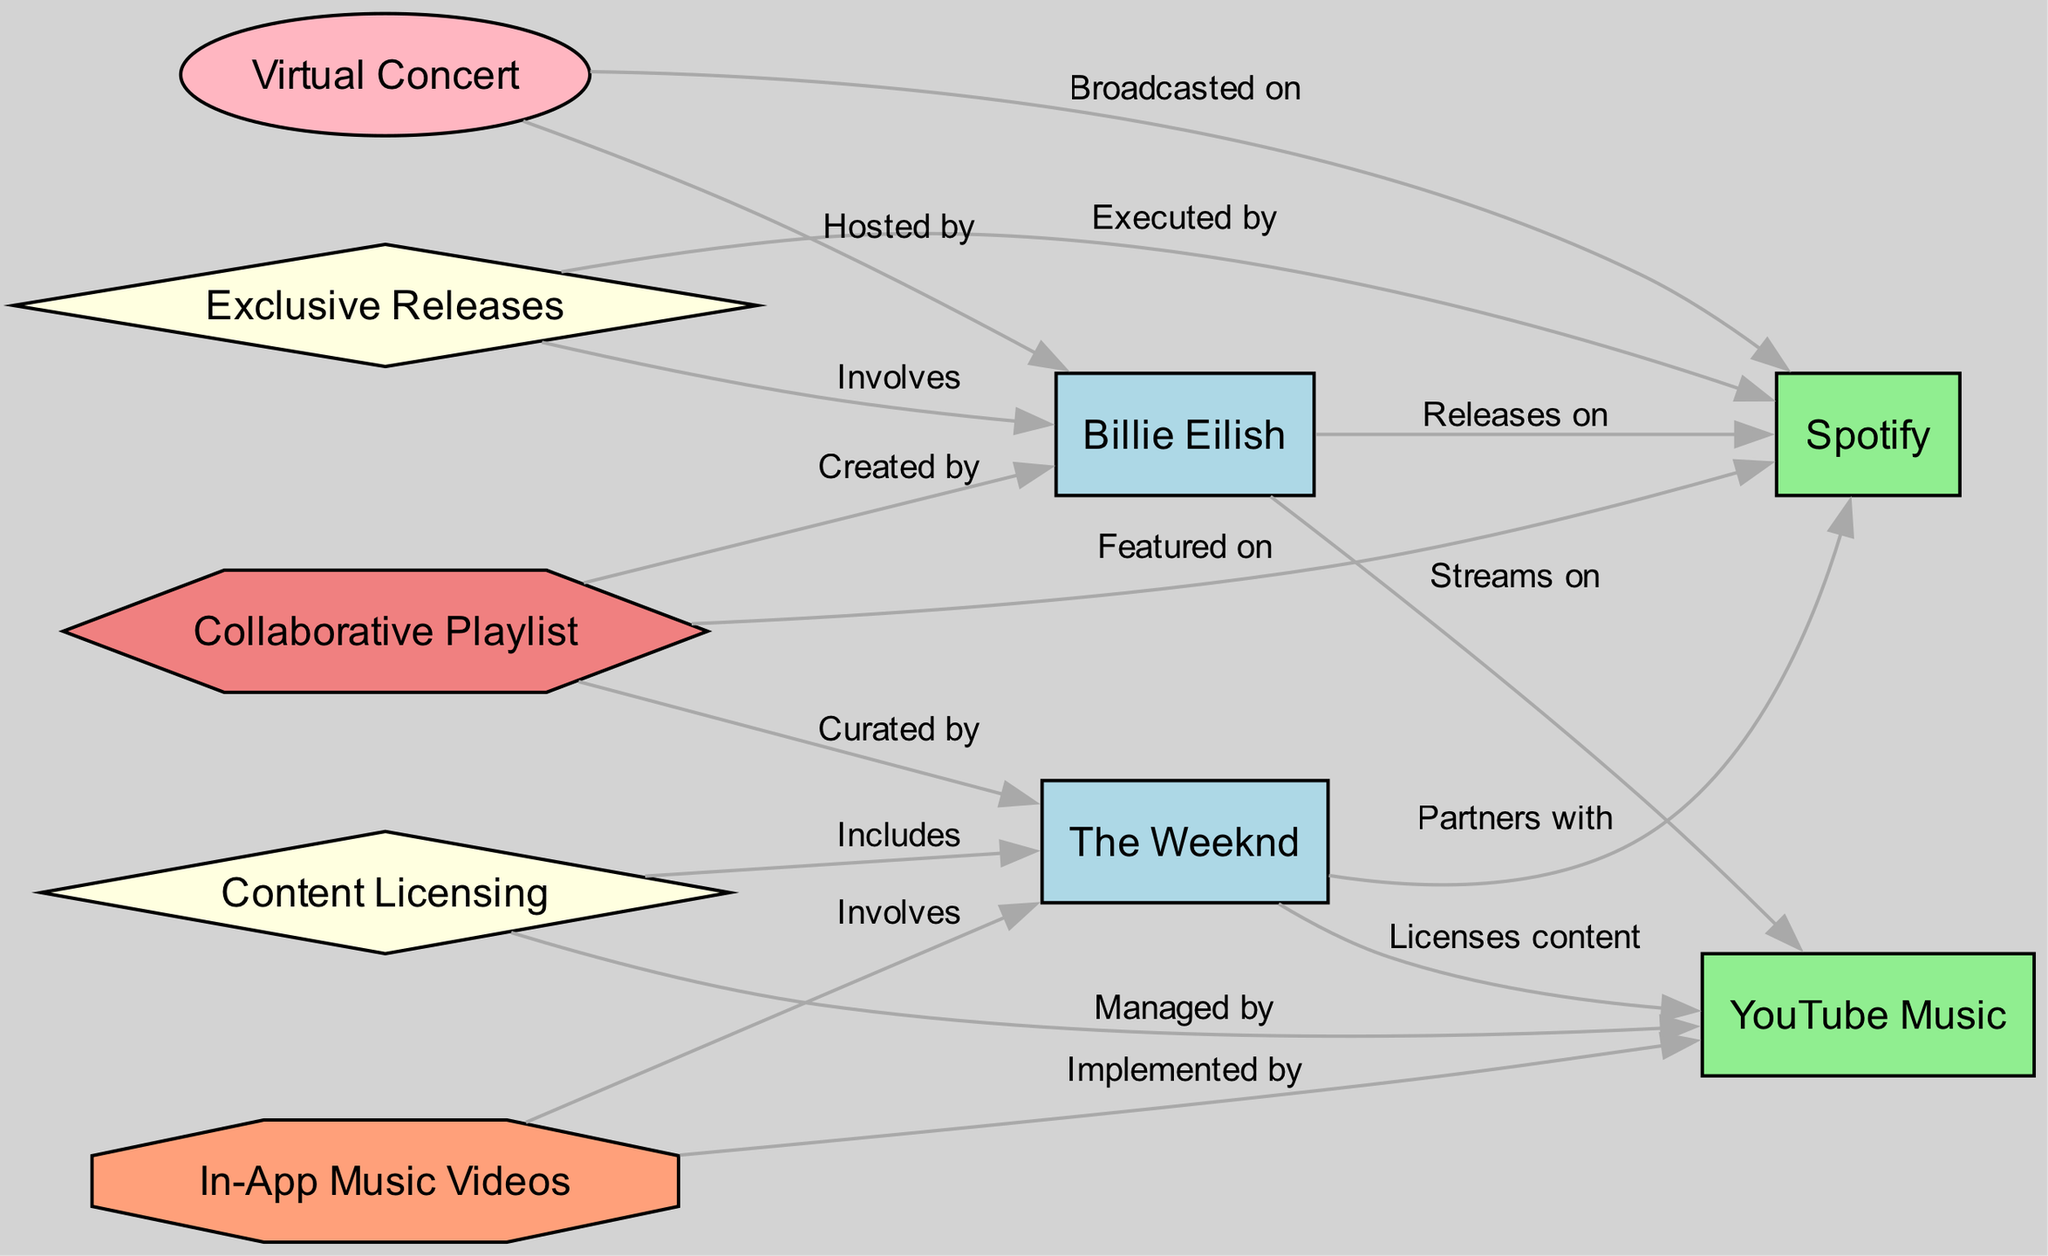What artists are involved in exclusive releases? The diagram shows that Billie Eilish is involved in exclusive releases, specifically linked to the partnership labeled "Exclusive Releases." Since this partnership connects directly to only one artist, Billie Eilish is the artist involved.
Answer: Billie Eilish Which developer manages content licensing for The Weeknd? According to the diagram, The Weeknd licenses content through the developer identified as YouTube Music. This relationship is directly shown in the edge connecting "The Weeknd" (Artist2) and "YouTube Music" (Developer2) with the label "Licenses content."
Answer: YouTube Music How many partnerships are shown in the diagram? The diagram contains two partnerships: "Exclusive Releases" and "Content Licensing." There is a straightforward count of the partnership nodes, and both partnerships can be seen connected to artists and developers.
Answer: 2 Who hosted the virtual concert? The diagram indicates that the virtual concert is hosted by Billie Eilish, as shown by the connection labeled "Hosted by" between "Virtual Concert" (Event1) and "Billie Eilish" (Artist1).
Answer: Billie Eilish What feature involves The Weeknd? The diagram shows that the feature "In-App Music Videos" involves The Weeknd. This can be determined from the edge connecting "In-App Music Videos" (Feature1) to "The Weeknd" (Artist2) with the label "Involves."
Answer: In-App Music Videos Which artist streams on Spotify? From the diagram, it is clear that Billie Eilish streams on Spotify, as indicated by the edge labeled "Streams on" between "Billie Eilish" (Artist1) and "Spotify" (Developer1).
Answer: Billie Eilish What type of product is the collaborative playlist? The collaborative playlist is categorized as a product and depicted by the "Collaborative Playlist" node (Product1), which is in the shape of a hexagon in the diagram, as per the defined node shapes and colors.
Answer: Collaborative Playlist Which developers are involved with Billie Eilish? Billie Eilish is connected to two developers in the diagram: Spotify and YouTube Music. The relationship is shown through the edges "Releases on" with Spotify and "Streams on" with YouTube Music. Thus, both developers are involved with Billie Eilish.
Answer: Spotify, YouTube Music 